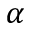<formula> <loc_0><loc_0><loc_500><loc_500>\alpha</formula> 